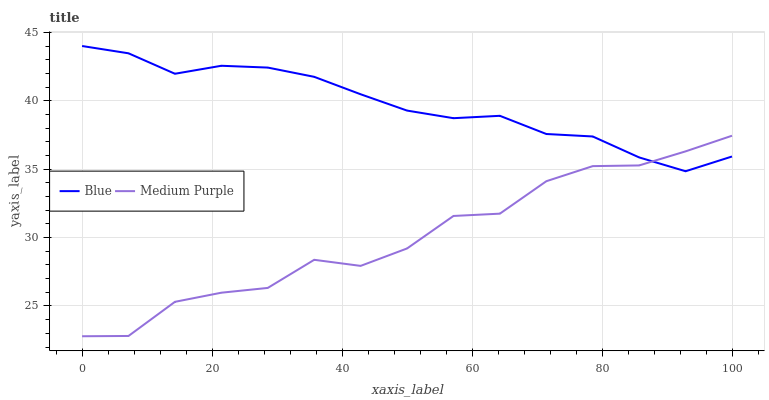Does Medium Purple have the minimum area under the curve?
Answer yes or no. Yes. Does Blue have the maximum area under the curve?
Answer yes or no. Yes. Does Medium Purple have the maximum area under the curve?
Answer yes or no. No. Is Blue the smoothest?
Answer yes or no. Yes. Is Medium Purple the roughest?
Answer yes or no. Yes. Is Medium Purple the smoothest?
Answer yes or no. No. Does Medium Purple have the lowest value?
Answer yes or no. Yes. Does Blue have the highest value?
Answer yes or no. Yes. Does Medium Purple have the highest value?
Answer yes or no. No. Does Medium Purple intersect Blue?
Answer yes or no. Yes. Is Medium Purple less than Blue?
Answer yes or no. No. Is Medium Purple greater than Blue?
Answer yes or no. No. 